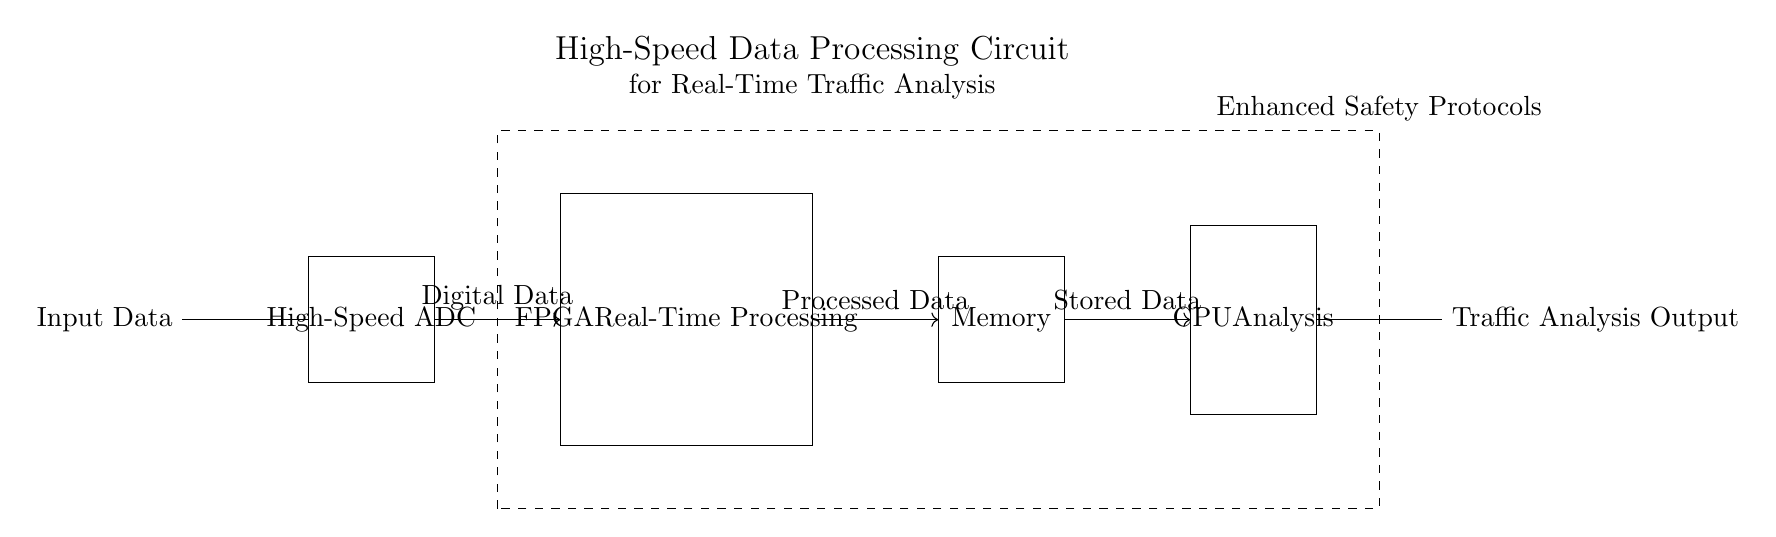What is the first component in the circuit? The first component listed in the circuit is "Input Data," located at the leftmost position, indicating where the data enters the system.
Answer: Input Data What type of processing does the FPGA perform? The FPGA is labeled "Real-Time Processing," which indicates its role in handling data swiftly for immediate use within the traffic analysis system.
Answer: Real-Time Processing How many main blocks are in the circuit diagram? There are four main blocks, which are the High-Speed ADC, FPGA, Memory, and CPU, as identified by the rectangles in the diagram.
Answer: Four What is the purpose of the Memory block? The Memory block is responsible for storing processed data temporarily, allowing for analysis by the CPU later in the circuit sequence.
Answer: Storing Data Which block is responsible for traffic analysis? The CPU block is labeled "Analysis," signifying its primary function to analyze the data that flows through the circuit.
Answer: CPU Analysis What encapsulates the entire circuit diagram? The entire circuit is surrounded by a dashed rectangle labeled "Enhanced Safety Protocols," indicating that these protocols oversee all components within the circuit for improved safety.
Answer: Enhanced Safety Protocols 